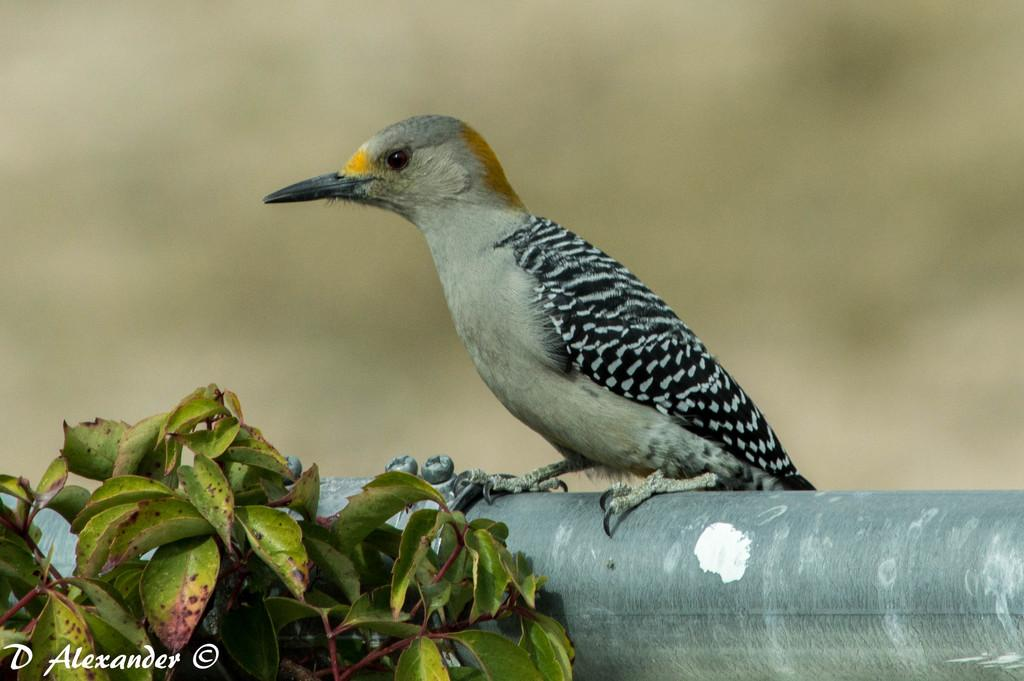What type of animal is in the image? There is a bird in the image. What color is the bird? The bird is black in color. What feature can be observed on the bird's face? The bird has a long beak. What is present in the image besides the bird? There is a tree in the image. How would you describe the background of the image? The background of the image is blurred. What type of soap is the bird using to clean its feathers in the image? There is no soap present in the image, and the bird is not shown cleaning its feathers. 